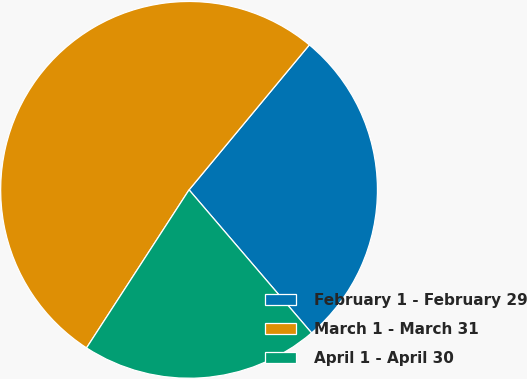Convert chart. <chart><loc_0><loc_0><loc_500><loc_500><pie_chart><fcel>February 1 - February 29<fcel>March 1 - March 31<fcel>April 1 - April 30<nl><fcel>27.71%<fcel>51.87%<fcel>20.43%<nl></chart> 